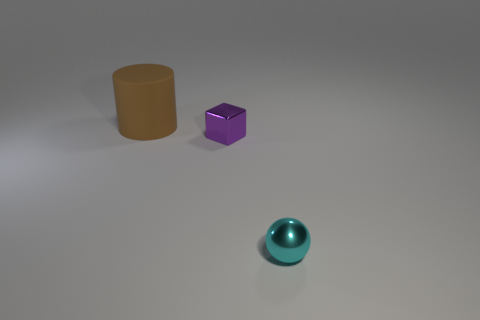Add 2 cyan spheres. How many objects exist? 5 Subtract all cubes. How many objects are left? 2 Subtract all tiny cubes. Subtract all blocks. How many objects are left? 1 Add 3 cyan metallic spheres. How many cyan metallic spheres are left? 4 Add 1 metal things. How many metal things exist? 3 Subtract 0 blue balls. How many objects are left? 3 